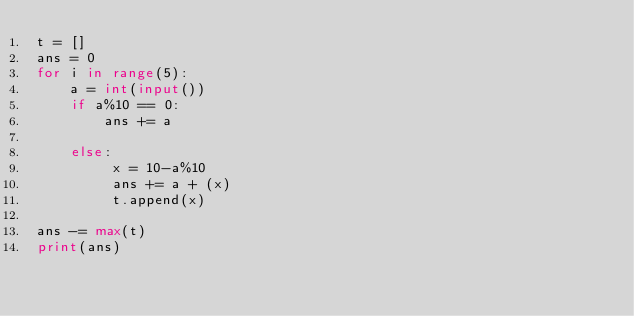Convert code to text. <code><loc_0><loc_0><loc_500><loc_500><_Python_>t = []
ans = 0
for i in range(5):
    a = int(input())
    if a%10 == 0:
        ans += a
    
    else:
         x = 10-a%10
         ans += a + (x)
         t.append(x)
    
ans -= max(t)
print(ans)</code> 